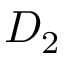<formula> <loc_0><loc_0><loc_500><loc_500>D _ { 2 }</formula> 